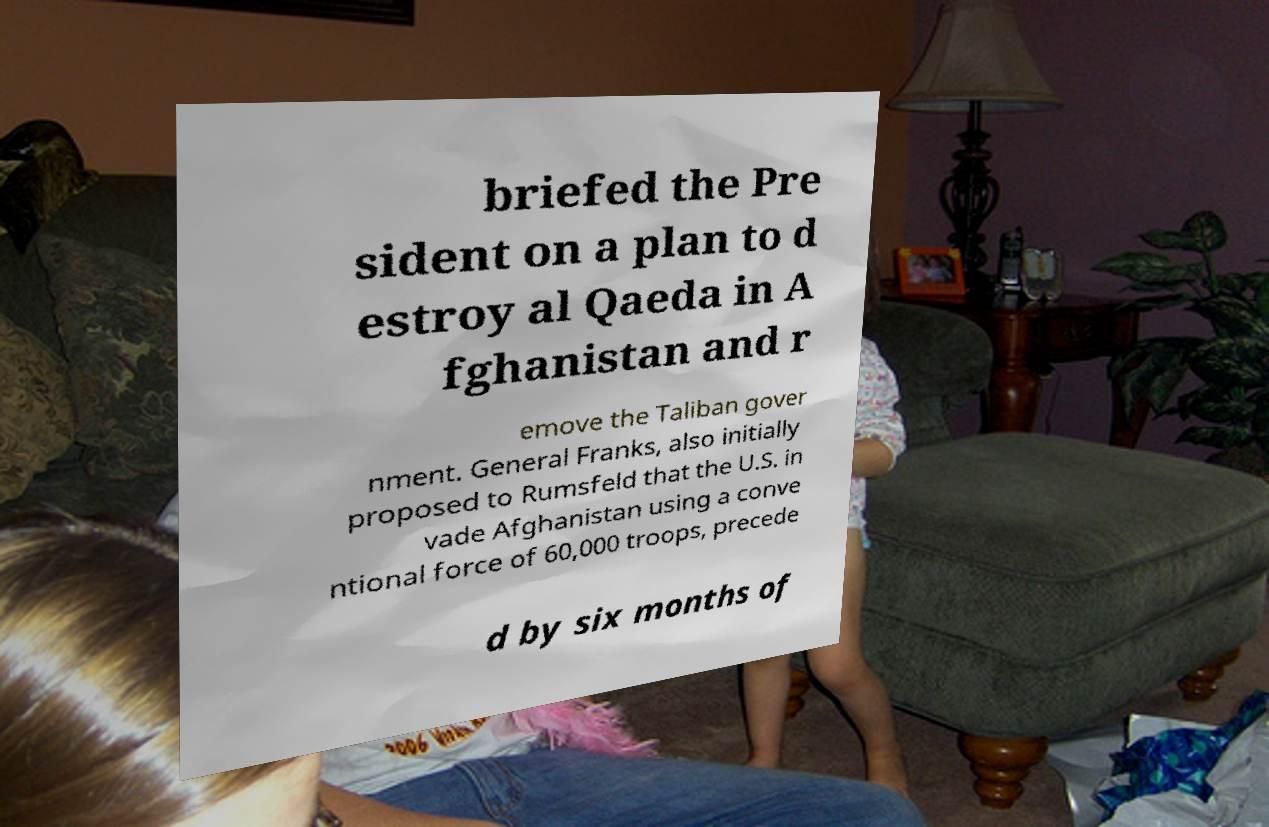Could you extract and type out the text from this image? briefed the Pre sident on a plan to d estroy al Qaeda in A fghanistan and r emove the Taliban gover nment. General Franks, also initially proposed to Rumsfeld that the U.S. in vade Afghanistan using a conve ntional force of 60,000 troops, precede d by six months of 